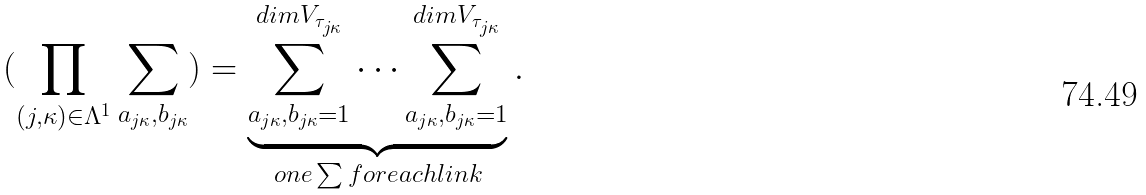<formula> <loc_0><loc_0><loc_500><loc_500>( \prod _ { ( j , \kappa ) \in \Lambda ^ { 1 } } \sum _ { a _ { j \kappa } , b _ { j \kappa } } ) = \underbrace { \sum _ { a _ { j \kappa } , b _ { j \kappa } = 1 } ^ { d i m V _ { \tau _ { j \kappa } } } \cdots \sum _ { a _ { j \kappa } , b _ { j \kappa } = 1 } ^ { d i m V _ { \tau _ { j \kappa } } } } _ { o n e \sum f o r e a c h l i n k } .</formula> 